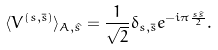Convert formula to latex. <formula><loc_0><loc_0><loc_500><loc_500>\langle V ^ { ( s , \bar { s } ) } \rangle _ { A , \hat { s } } = \frac { 1 } { \sqrt { 2 } } \delta _ { s , \bar { s } } e ^ { - i \pi \frac { s \hat { s } } { 2 } } .</formula> 